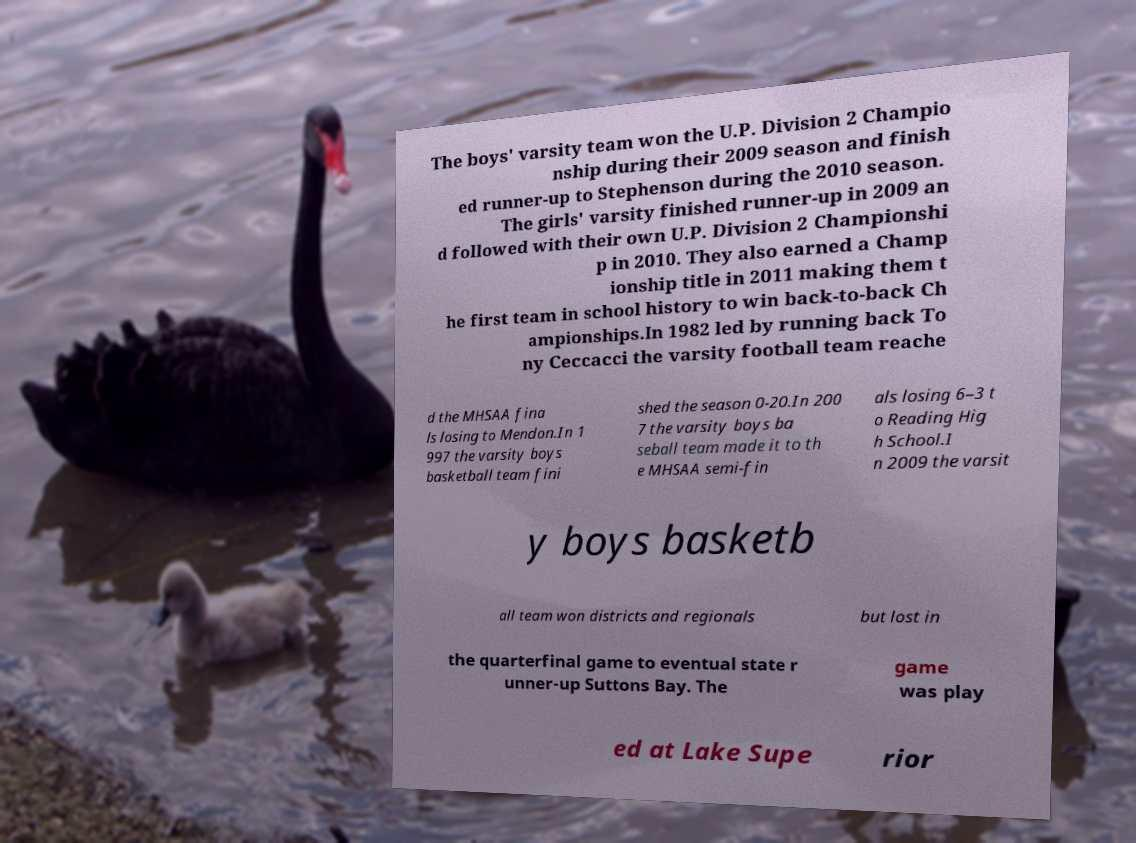I need the written content from this picture converted into text. Can you do that? The boys' varsity team won the U.P. Division 2 Champio nship during their 2009 season and finish ed runner-up to Stephenson during the 2010 season. The girls' varsity finished runner-up in 2009 an d followed with their own U.P. Division 2 Championshi p in 2010. They also earned a Champ ionship title in 2011 making them t he first team in school history to win back-to-back Ch ampionships.In 1982 led by running back To ny Ceccacci the varsity football team reache d the MHSAA fina ls losing to Mendon.In 1 997 the varsity boys basketball team fini shed the season 0-20.In 200 7 the varsity boys ba seball team made it to th e MHSAA semi-fin als losing 6–3 t o Reading Hig h School.I n 2009 the varsit y boys basketb all team won districts and regionals but lost in the quarterfinal game to eventual state r unner-up Suttons Bay. The game was play ed at Lake Supe rior 